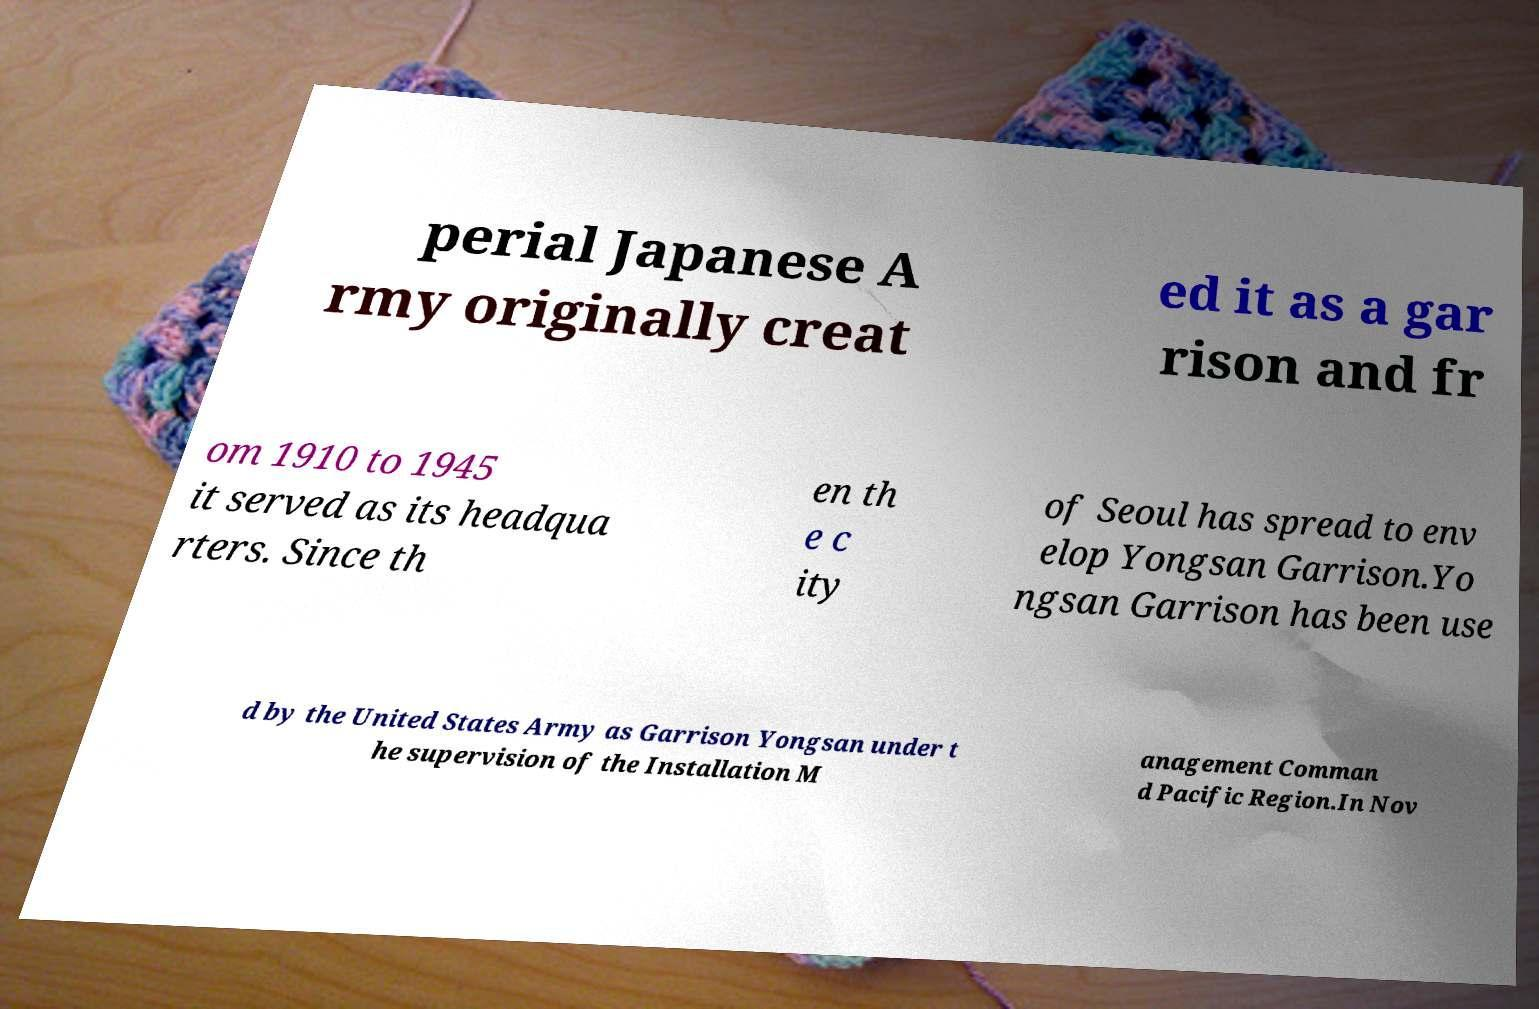Please read and relay the text visible in this image. What does it say? perial Japanese A rmy originally creat ed it as a gar rison and fr om 1910 to 1945 it served as its headqua rters. Since th en th e c ity of Seoul has spread to env elop Yongsan Garrison.Yo ngsan Garrison has been use d by the United States Army as Garrison Yongsan under t he supervision of the Installation M anagement Comman d Pacific Region.In Nov 